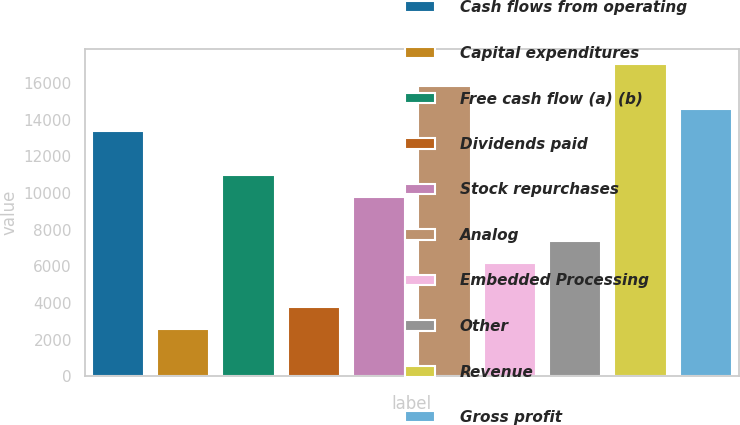Convert chart to OTSL. <chart><loc_0><loc_0><loc_500><loc_500><bar_chart><fcel>Cash flows from operating<fcel>Capital expenditures<fcel>Free cash flow (a) (b)<fcel>Dividends paid<fcel>Stock repurchases<fcel>Analog<fcel>Embedded Processing<fcel>Other<fcel>Revenue<fcel>Gross profit<nl><fcel>13406.6<fcel>2592.2<fcel>11003.4<fcel>3793.8<fcel>9801.8<fcel>15809.8<fcel>6197<fcel>7398.6<fcel>17011.4<fcel>14608.2<nl></chart> 